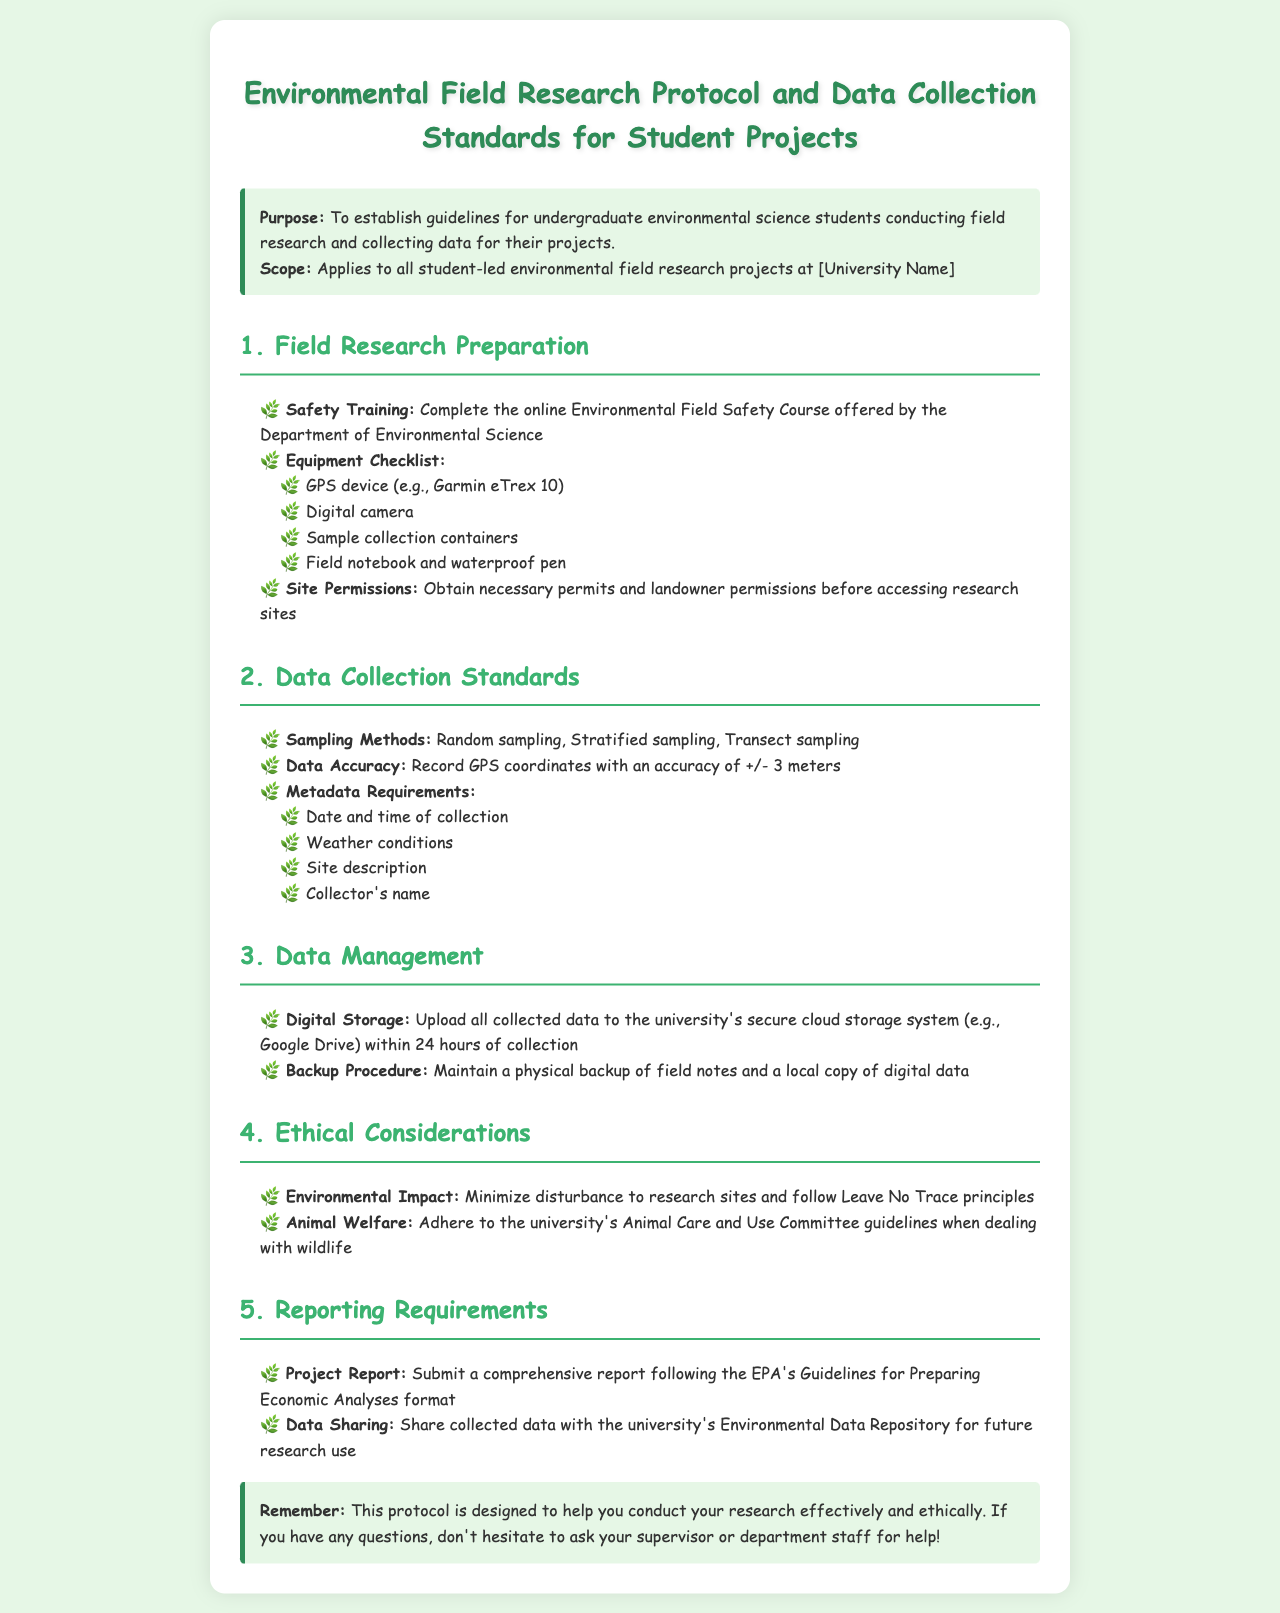What is the purpose of the protocol? The purpose is to establish guidelines for undergraduate environmental science students conducting field research and collecting data for their projects.
Answer: To establish guidelines for undergraduate environmental science students conducting field research What type of training is required before field research? The document specifies that students must complete an online Environmental Field Safety Course offered by the Department of Environmental Science.
Answer: Environmental Field Safety Course What is the accuracy requirement for GPS coordinates? The document states that GPS coordinates must be recorded with an accuracy of +/- 3 meters.
Answer: +/- 3 meters What are the metadata requirements for data collection? The requirements include several items such as date and time of collection, weather conditions, site description, and collector's name.
Answer: Date and time of collection, weather conditions, site description, collector's name How soon must collected data be uploaded to the university's storage system? The protocol indicates that all collected data should be uploaded within 24 hours of collection.
Answer: 24 hours Which principles should be followed to minimize environmental impact? The document refers to the Leave No Trace principles as a guideline for minimizing disturbance.
Answer: Leave No Trace principles What is the required format for submitting the project report? Students are instructed to follow the EPA's Guidelines for Preparing Economic Analyses format for their reports.
Answer: EPA's Guidelines for Preparing Economic Analyses What committee's guidelines must be adhered to when dealing with wildlife? The document mentions adhering to the university's Animal Care and Use Committee guidelines.
Answer: Animal Care and Use Committee guidelines In which repository should collected data be shared? The protocol states that data should be shared with the university's Environmental Data Repository.
Answer: Environmental Data Repository 